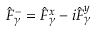Convert formula to latex. <formula><loc_0><loc_0><loc_500><loc_500>\hat { F } _ { \gamma } ^ { - } = \hat { F } _ { \gamma } ^ { x } - i \hat { F } _ { \gamma } ^ { y }</formula> 